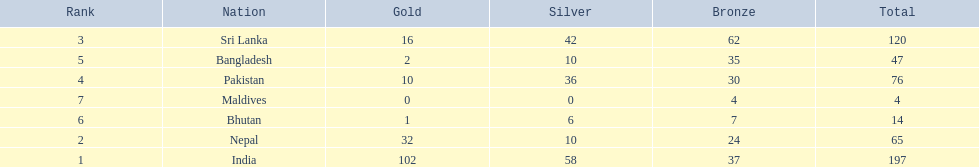What are the total number of bronze medals sri lanka have earned? 62. 